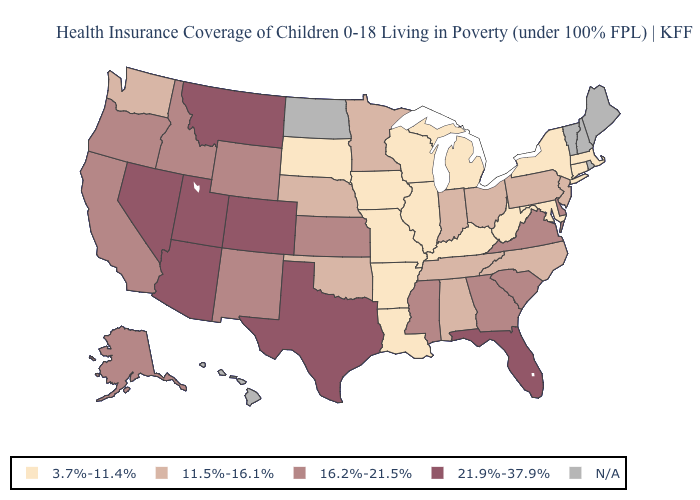Does the first symbol in the legend represent the smallest category?
Short answer required. Yes. Among the states that border Tennessee , does Arkansas have the lowest value?
Quick response, please. Yes. Name the states that have a value in the range 11.5%-16.1%?
Short answer required. Alabama, Indiana, Minnesota, Nebraska, New Jersey, North Carolina, Ohio, Oklahoma, Pennsylvania, Tennessee, Washington. What is the highest value in the USA?
Answer briefly. 21.9%-37.9%. Among the states that border Idaho , does Utah have the highest value?
Keep it brief. Yes. Does Arkansas have the lowest value in the USA?
Keep it brief. Yes. What is the lowest value in states that border Virginia?
Quick response, please. 3.7%-11.4%. Does Montana have the highest value in the West?
Quick response, please. Yes. Among the states that border Colorado , which have the highest value?
Quick response, please. Arizona, Utah. What is the highest value in the West ?
Quick response, please. 21.9%-37.9%. Is the legend a continuous bar?
Answer briefly. No. Does the map have missing data?
Short answer required. Yes. Name the states that have a value in the range 11.5%-16.1%?
Quick response, please. Alabama, Indiana, Minnesota, Nebraska, New Jersey, North Carolina, Ohio, Oklahoma, Pennsylvania, Tennessee, Washington. What is the lowest value in states that border North Carolina?
Keep it brief. 11.5%-16.1%. 